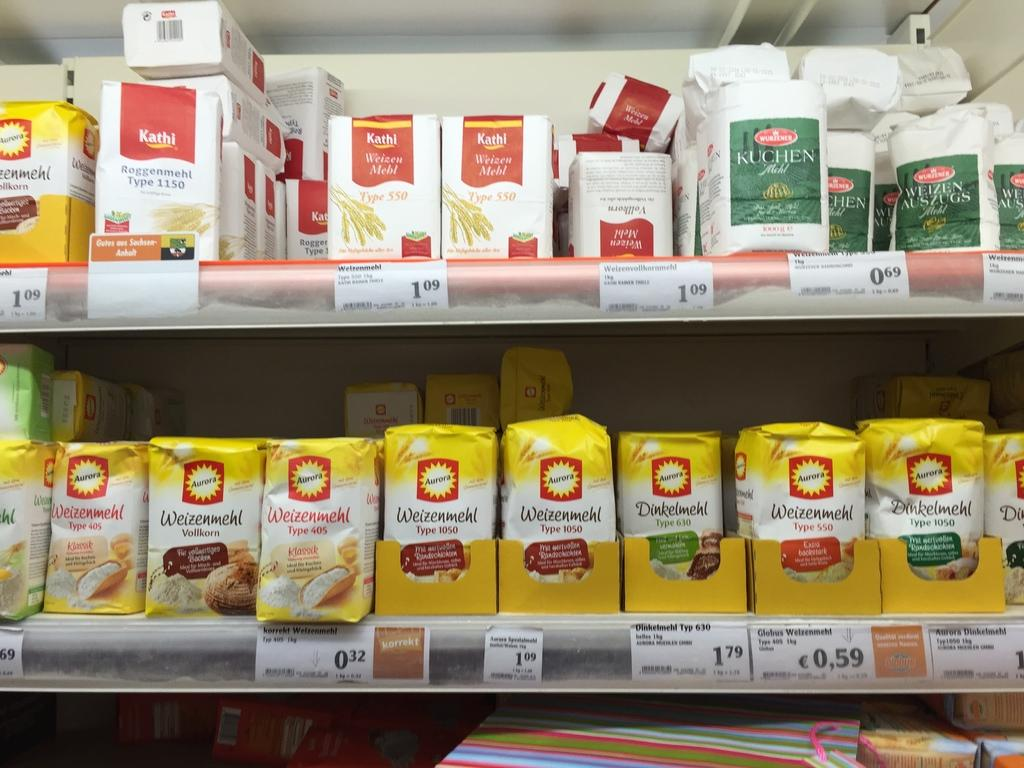Provide a one-sentence caption for the provided image. Different brands and types of flour are stacked on two shelves. 